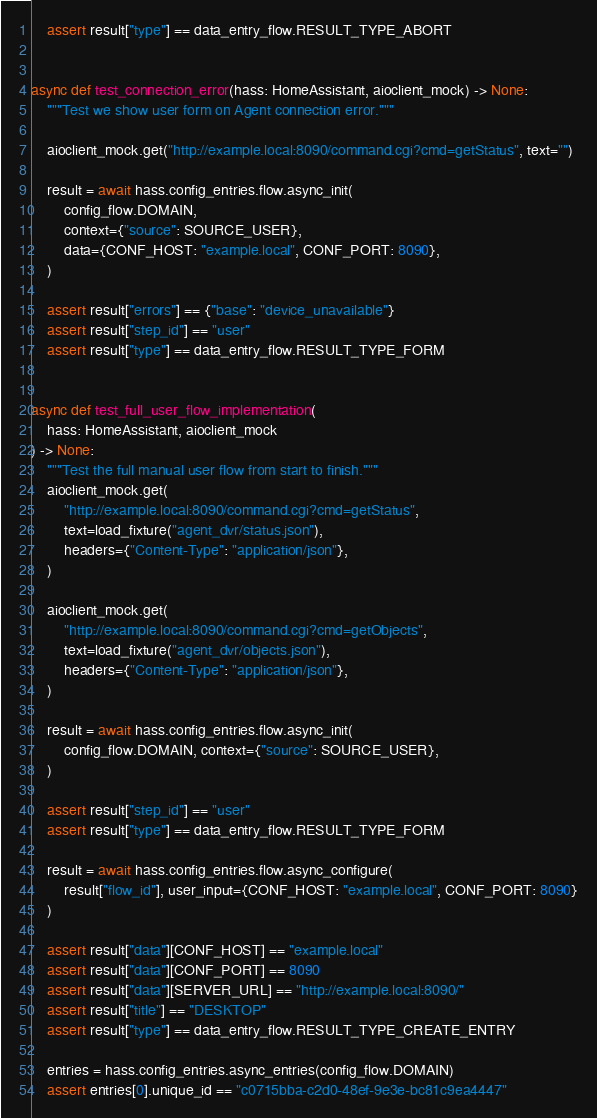<code> <loc_0><loc_0><loc_500><loc_500><_Python_>
    assert result["type"] == data_entry_flow.RESULT_TYPE_ABORT


async def test_connection_error(hass: HomeAssistant, aioclient_mock) -> None:
    """Test we show user form on Agent connection error."""

    aioclient_mock.get("http://example.local:8090/command.cgi?cmd=getStatus", text="")

    result = await hass.config_entries.flow.async_init(
        config_flow.DOMAIN,
        context={"source": SOURCE_USER},
        data={CONF_HOST: "example.local", CONF_PORT: 8090},
    )

    assert result["errors"] == {"base": "device_unavailable"}
    assert result["step_id"] == "user"
    assert result["type"] == data_entry_flow.RESULT_TYPE_FORM


async def test_full_user_flow_implementation(
    hass: HomeAssistant, aioclient_mock
) -> None:
    """Test the full manual user flow from start to finish."""
    aioclient_mock.get(
        "http://example.local:8090/command.cgi?cmd=getStatus",
        text=load_fixture("agent_dvr/status.json"),
        headers={"Content-Type": "application/json"},
    )

    aioclient_mock.get(
        "http://example.local:8090/command.cgi?cmd=getObjects",
        text=load_fixture("agent_dvr/objects.json"),
        headers={"Content-Type": "application/json"},
    )

    result = await hass.config_entries.flow.async_init(
        config_flow.DOMAIN, context={"source": SOURCE_USER},
    )

    assert result["step_id"] == "user"
    assert result["type"] == data_entry_flow.RESULT_TYPE_FORM

    result = await hass.config_entries.flow.async_configure(
        result["flow_id"], user_input={CONF_HOST: "example.local", CONF_PORT: 8090}
    )

    assert result["data"][CONF_HOST] == "example.local"
    assert result["data"][CONF_PORT] == 8090
    assert result["data"][SERVER_URL] == "http://example.local:8090/"
    assert result["title"] == "DESKTOP"
    assert result["type"] == data_entry_flow.RESULT_TYPE_CREATE_ENTRY

    entries = hass.config_entries.async_entries(config_flow.DOMAIN)
    assert entries[0].unique_id == "c0715bba-c2d0-48ef-9e3e-bc81c9ea4447"
</code> 